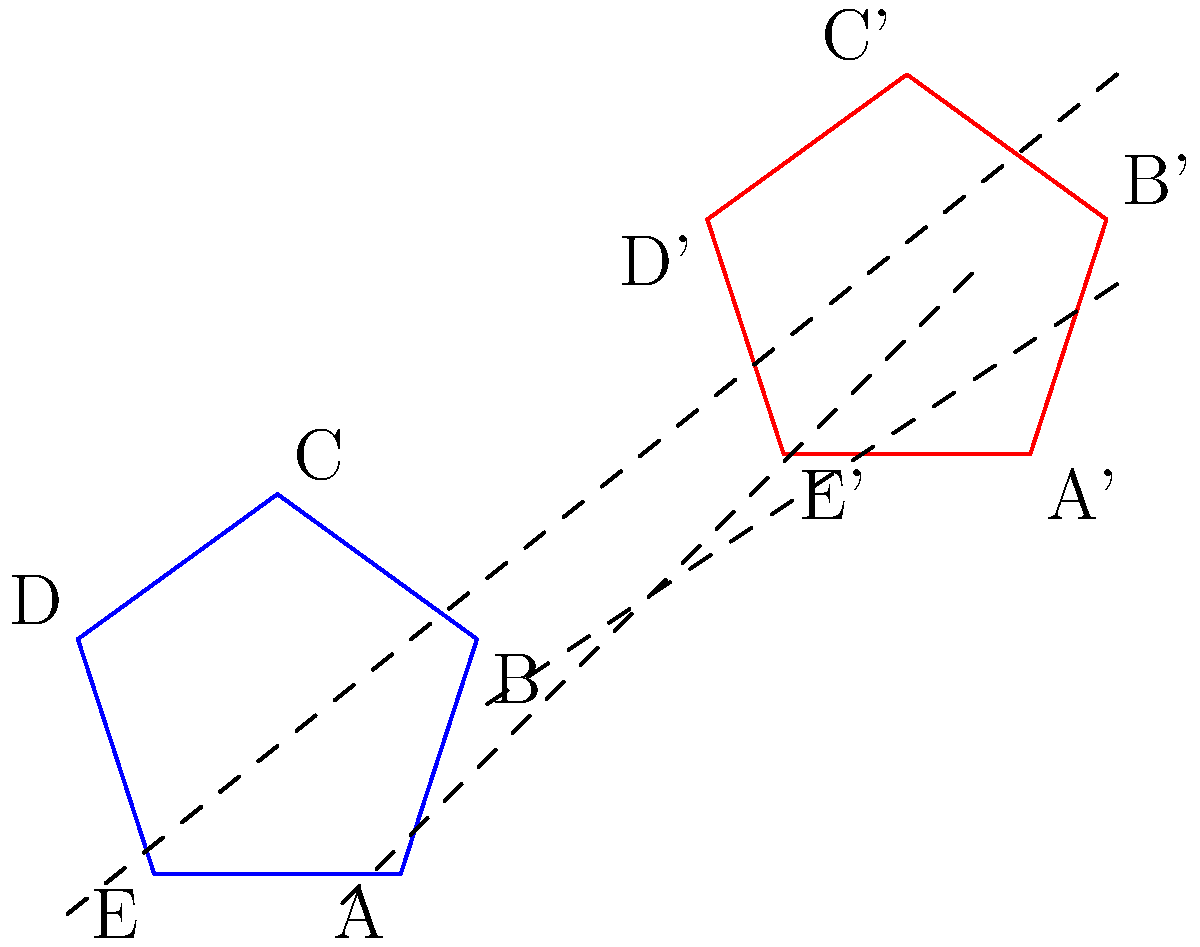In a recently discovered Martian crop circle formation, two congruent pentagons ABCDE and A'B'C'D'E' were found. If the formation shows that the pentagons are related by a translation, what is the vector of translation from pentagon ABCDE to pentagon A'B'C'D'E'? To find the vector of translation from pentagon ABCDE to pentagon A'B'C'D'E', we need to follow these steps:

1. Identify corresponding points in the two pentagons. We can choose any pair of corresponding points, such as A and A'.

2. Determine the horizontal and vertical components of the translation:
   a. Horizontal component: A' is 3 units to the right of A
   b. Vertical component: A' is 2 units above A

3. Express the translation as a vector:
   The vector of translation is $\vec{v} = (3, 2)$

4. Verify the translation:
   We can check that this vector works for all other corresponding points:
   B to B': (3, 2)
   C to C': (3, 2)
   D to D': (3, 2)
   E to E': (3, 2)

5. Conclusion:
   The vector of translation from pentagon ABCDE to pentagon A'B'C'D'E' is $\vec{v} = (3, 2)$

This translation vector represents the uniform shift applied to all points of the original pentagon to obtain the corresponding points of the translated pentagon.
Answer: $(3, 2)$ 